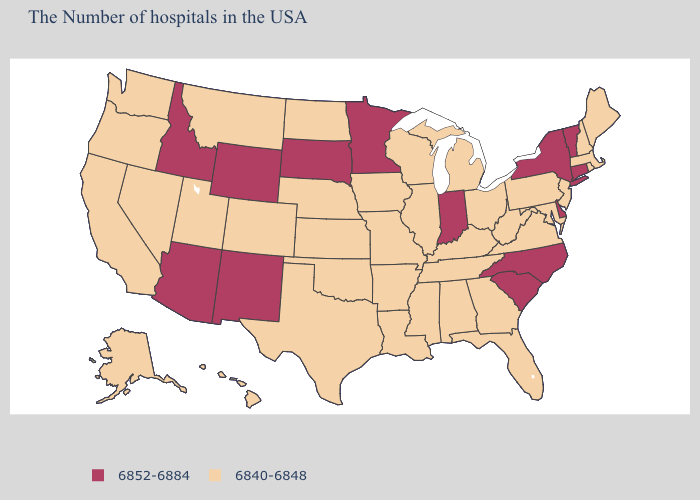Does the map have missing data?
Be succinct. No. Name the states that have a value in the range 6852-6884?
Be succinct. Vermont, Connecticut, New York, Delaware, North Carolina, South Carolina, Indiana, Minnesota, South Dakota, Wyoming, New Mexico, Arizona, Idaho. Among the states that border South Dakota , which have the lowest value?
Quick response, please. Iowa, Nebraska, North Dakota, Montana. Which states hav the highest value in the MidWest?
Give a very brief answer. Indiana, Minnesota, South Dakota. Name the states that have a value in the range 6840-6848?
Answer briefly. Maine, Massachusetts, Rhode Island, New Hampshire, New Jersey, Maryland, Pennsylvania, Virginia, West Virginia, Ohio, Florida, Georgia, Michigan, Kentucky, Alabama, Tennessee, Wisconsin, Illinois, Mississippi, Louisiana, Missouri, Arkansas, Iowa, Kansas, Nebraska, Oklahoma, Texas, North Dakota, Colorado, Utah, Montana, Nevada, California, Washington, Oregon, Alaska, Hawaii. Among the states that border Washington , which have the lowest value?
Short answer required. Oregon. What is the value of Colorado?
Keep it brief. 6840-6848. Does Massachusetts have a higher value than New Mexico?
Concise answer only. No. Does Oregon have the lowest value in the USA?
Keep it brief. Yes. Does the map have missing data?
Keep it brief. No. Name the states that have a value in the range 6852-6884?
Concise answer only. Vermont, Connecticut, New York, Delaware, North Carolina, South Carolina, Indiana, Minnesota, South Dakota, Wyoming, New Mexico, Arizona, Idaho. What is the value of Delaware?
Write a very short answer. 6852-6884. What is the value of Florida?
Give a very brief answer. 6840-6848. What is the highest value in the Northeast ?
Keep it brief. 6852-6884. What is the highest value in states that border Pennsylvania?
Concise answer only. 6852-6884. 